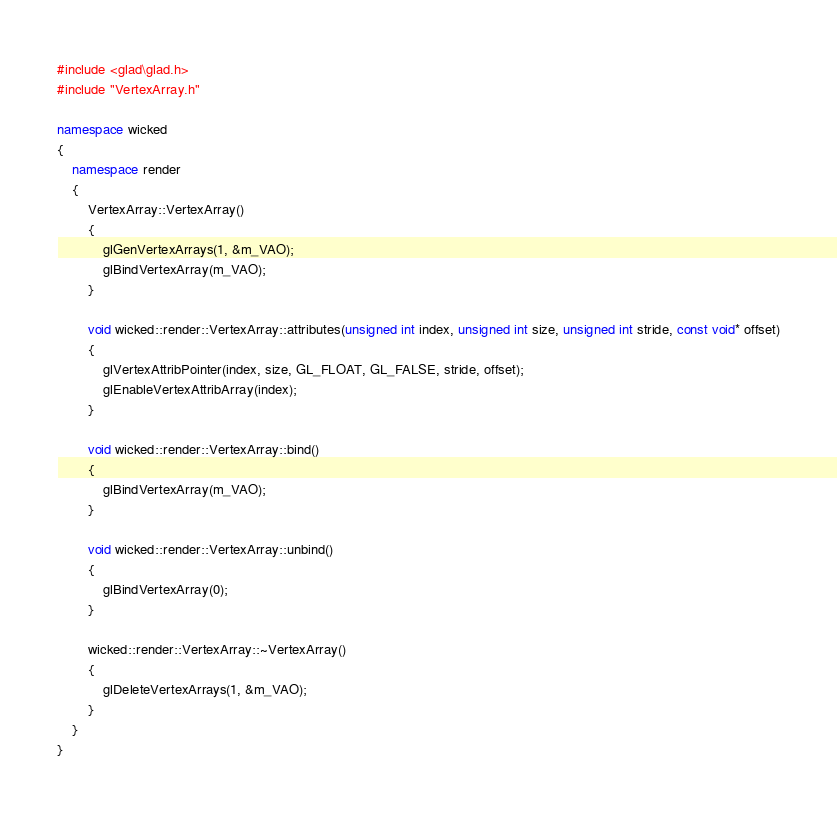<code> <loc_0><loc_0><loc_500><loc_500><_C++_>#include <glad\glad.h>
#include "VertexArray.h"

namespace wicked
{
	namespace render
	{
		VertexArray::VertexArray()
		{
			glGenVertexArrays(1, &m_VAO);
			glBindVertexArray(m_VAO);
		}

		void wicked::render::VertexArray::attributes(unsigned int index, unsigned int size, unsigned int stride, const void* offset)
		{
			glVertexAttribPointer(index, size, GL_FLOAT, GL_FALSE, stride, offset);
			glEnableVertexAttribArray(index);
		}

		void wicked::render::VertexArray::bind()
		{
			glBindVertexArray(m_VAO);
		}

		void wicked::render::VertexArray::unbind()
		{
			glBindVertexArray(0);
		}

		wicked::render::VertexArray::~VertexArray()
		{
			glDeleteVertexArrays(1, &m_VAO);
		}
	}
}</code> 